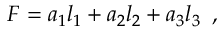Convert formula to latex. <formula><loc_0><loc_0><loc_500><loc_500>F = a _ { 1 } l _ { 1 } + a _ { 2 } l _ { 2 } + a _ { 3 } l _ { 3 } \, ,</formula> 